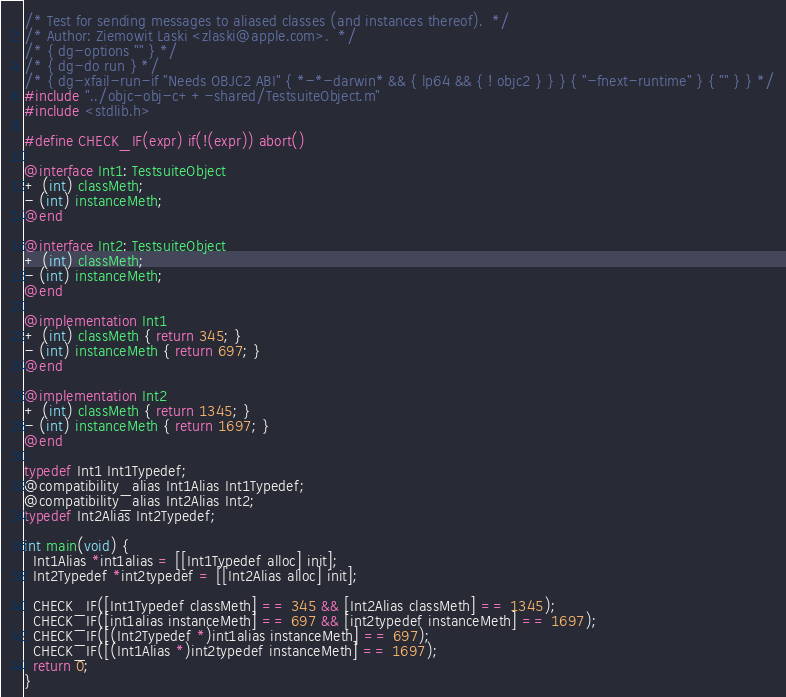<code> <loc_0><loc_0><loc_500><loc_500><_ObjectiveC_>/* Test for sending messages to aliased classes (and instances thereof).  */
/* Author: Ziemowit Laski <zlaski@apple.com>.  */
/* { dg-options "" } */
/* { dg-do run } */
/* { dg-xfail-run-if "Needs OBJC2 ABI" { *-*-darwin* && { lp64 && { ! objc2 } } } { "-fnext-runtime" } { "" } } */
#include "../objc-obj-c++-shared/TestsuiteObject.m"
#include <stdlib.h>

#define CHECK_IF(expr) if(!(expr)) abort()

@interface Int1: TestsuiteObject
+ (int) classMeth;
- (int) instanceMeth;
@end

@interface Int2: TestsuiteObject
+ (int) classMeth;      
- (int) instanceMeth;
@end

@implementation Int1
+ (int) classMeth { return 345; }
- (int) instanceMeth { return 697; }
@end

@implementation Int2
+ (int) classMeth { return 1345; }
- (int) instanceMeth { return 1697; }
@end

typedef Int1 Int1Typedef;
@compatibility_alias Int1Alias Int1Typedef;
@compatibility_alias Int2Alias Int2;
typedef Int2Alias Int2Typedef;                  

int main(void) {
  Int1Alias *int1alias = [[Int1Typedef alloc] init];
  Int2Typedef *int2typedef = [[Int2Alias alloc] init];

  CHECK_IF([Int1Typedef classMeth] == 345 && [Int2Alias classMeth] == 1345);
  CHECK_IF([int1alias instanceMeth] == 697 && [int2typedef instanceMeth] == 1697);
  CHECK_IF([(Int2Typedef *)int1alias instanceMeth] == 697);
  CHECK_IF([(Int1Alias *)int2typedef instanceMeth] == 1697);
  return 0;
}

</code> 